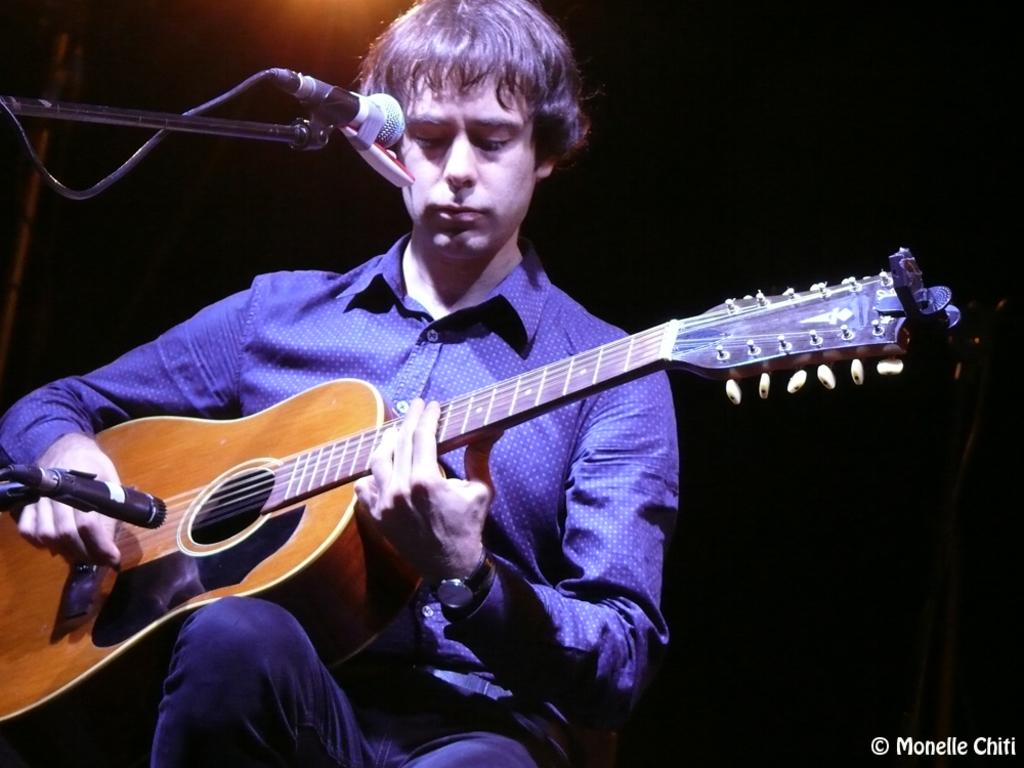What is the main subject of the image? There is a boy in the middle of the image. What is the boy holding in the image? The boy is holding a yellow-colored music instrument. Can you describe another object in the image? There is a black-colored microphone in the image. How many birds are flying around the boy in the image? There are no birds visible in the image. 